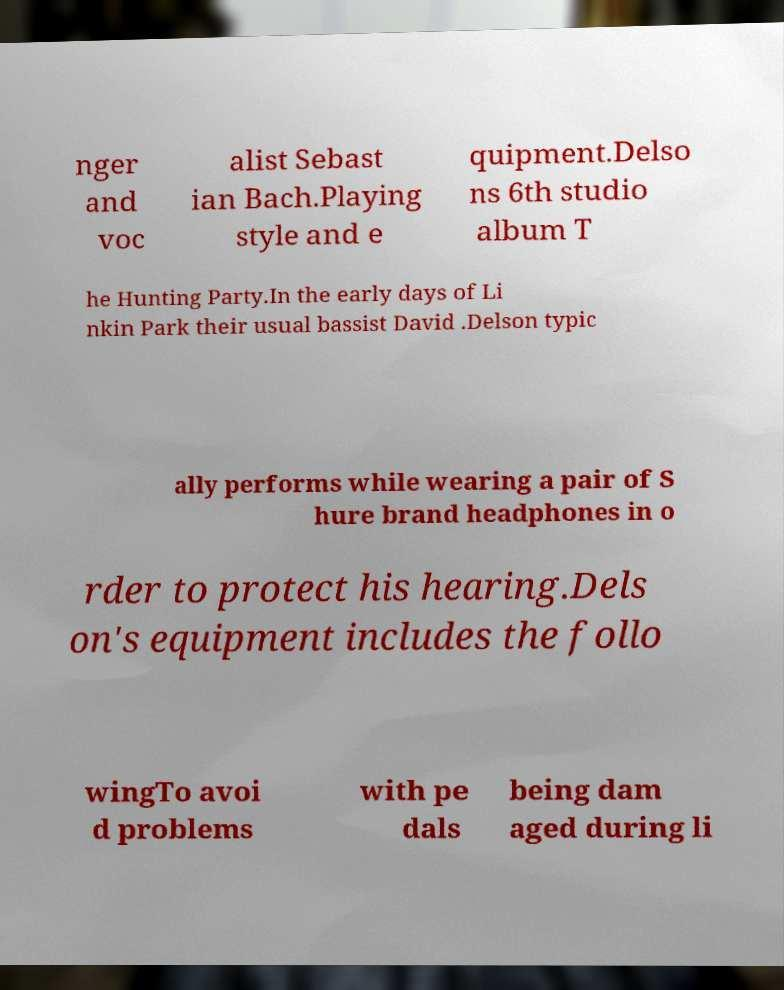Could you assist in decoding the text presented in this image and type it out clearly? nger and voc alist Sebast ian Bach.Playing style and e quipment.Delso ns 6th studio album T he Hunting Party.In the early days of Li nkin Park their usual bassist David .Delson typic ally performs while wearing a pair of S hure brand headphones in o rder to protect his hearing.Dels on's equipment includes the follo wingTo avoi d problems with pe dals being dam aged during li 